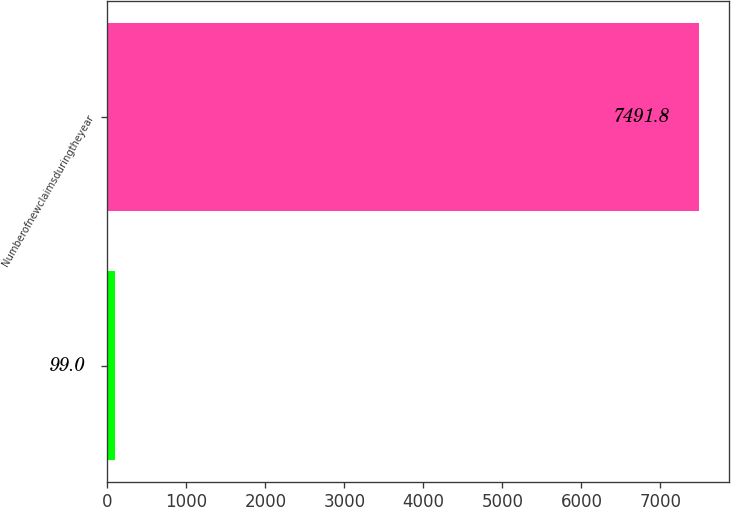Convert chart. <chart><loc_0><loc_0><loc_500><loc_500><bar_chart><ecel><fcel>Numberofnewclaimsduringtheyear<nl><fcel>99<fcel>7491.8<nl></chart> 